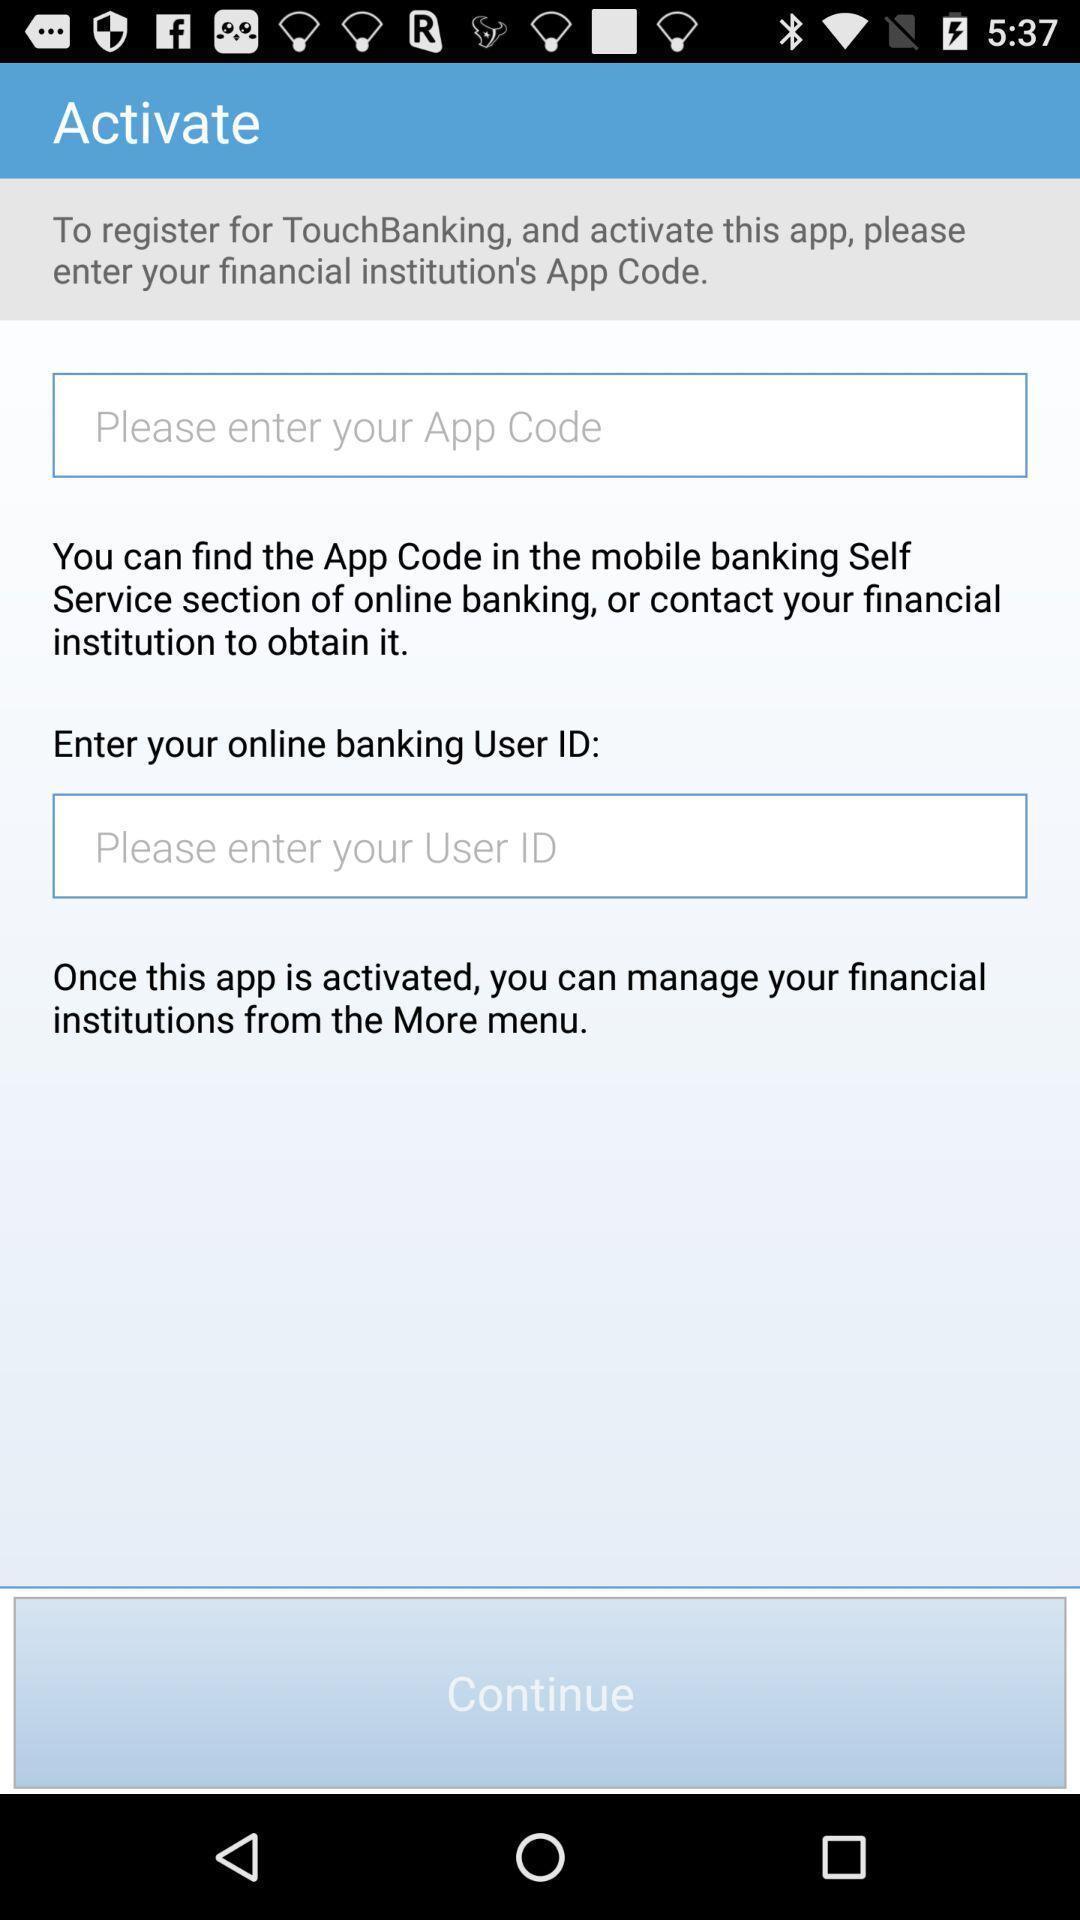Please provide a description for this image. Page that displaying financial application. 